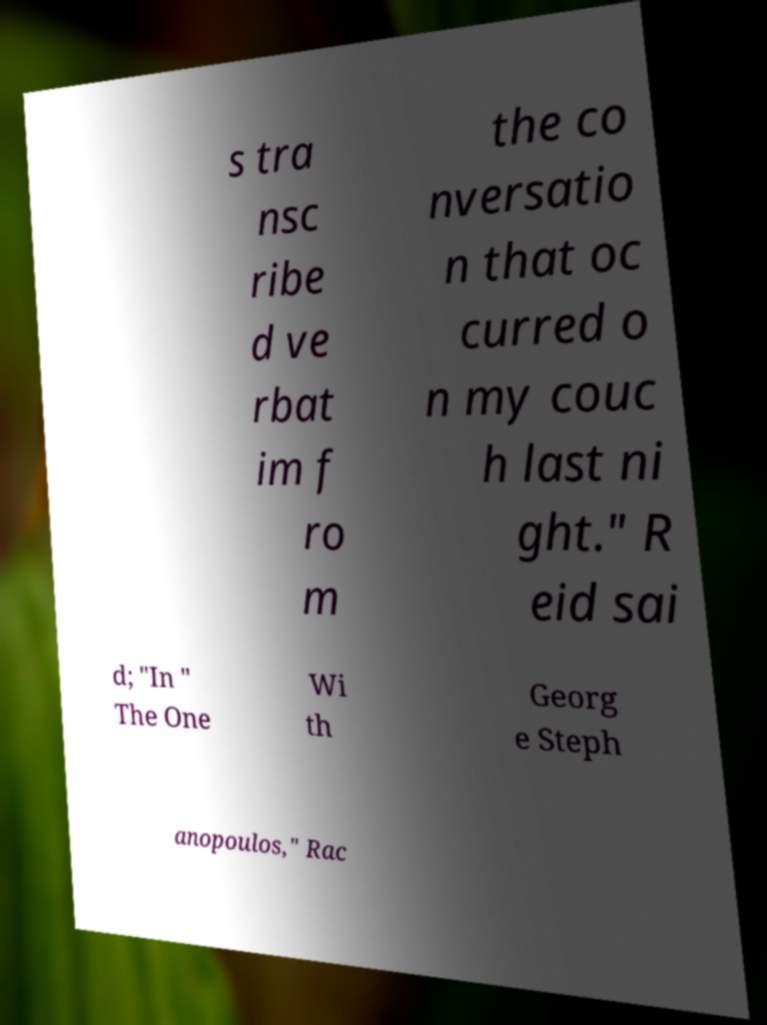What messages or text are displayed in this image? I need them in a readable, typed format. s tra nsc ribe d ve rbat im f ro m the co nversatio n that oc curred o n my couc h last ni ght." R eid sai d; "In " The One Wi th Georg e Steph anopoulos," Rac 